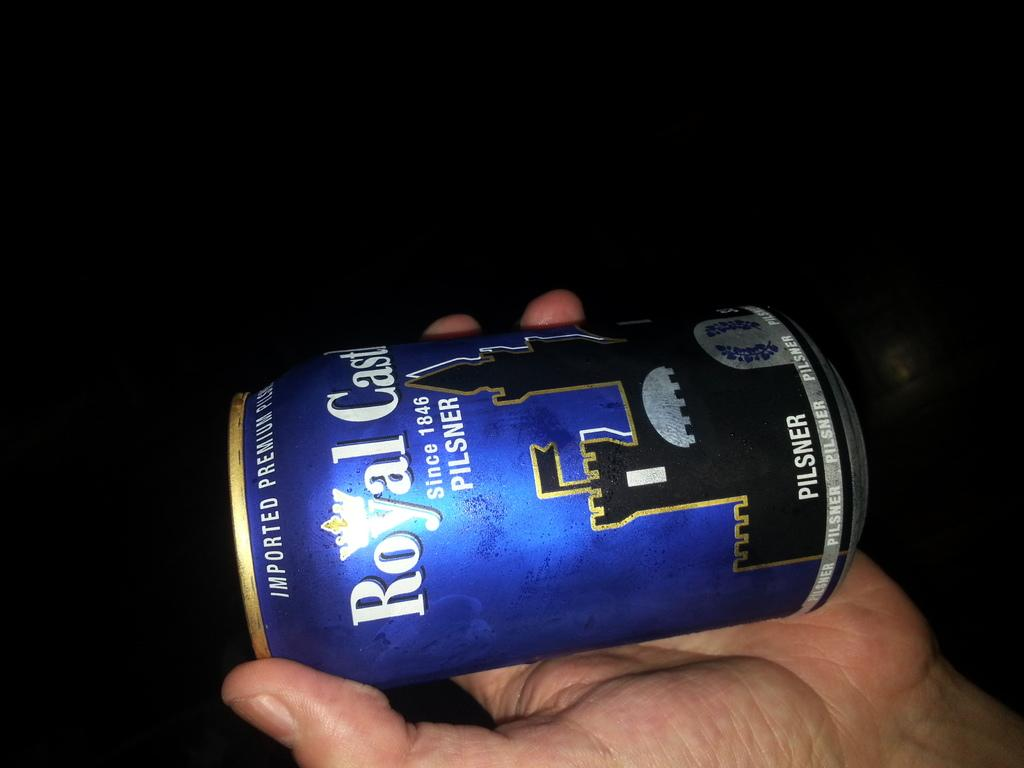Provide a one-sentence caption for the provided image. a bottle of beer called roayl castle looks like someone is holding it. 